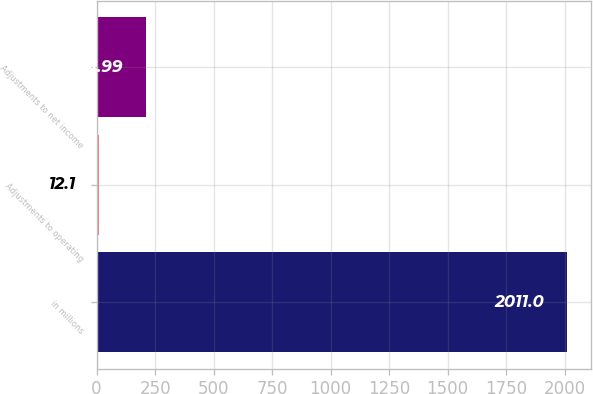Convert chart. <chart><loc_0><loc_0><loc_500><loc_500><bar_chart><fcel>in millions<fcel>Adjustments to operating<fcel>Adjustments to net income<nl><fcel>2011<fcel>12.1<fcel>211.99<nl></chart> 